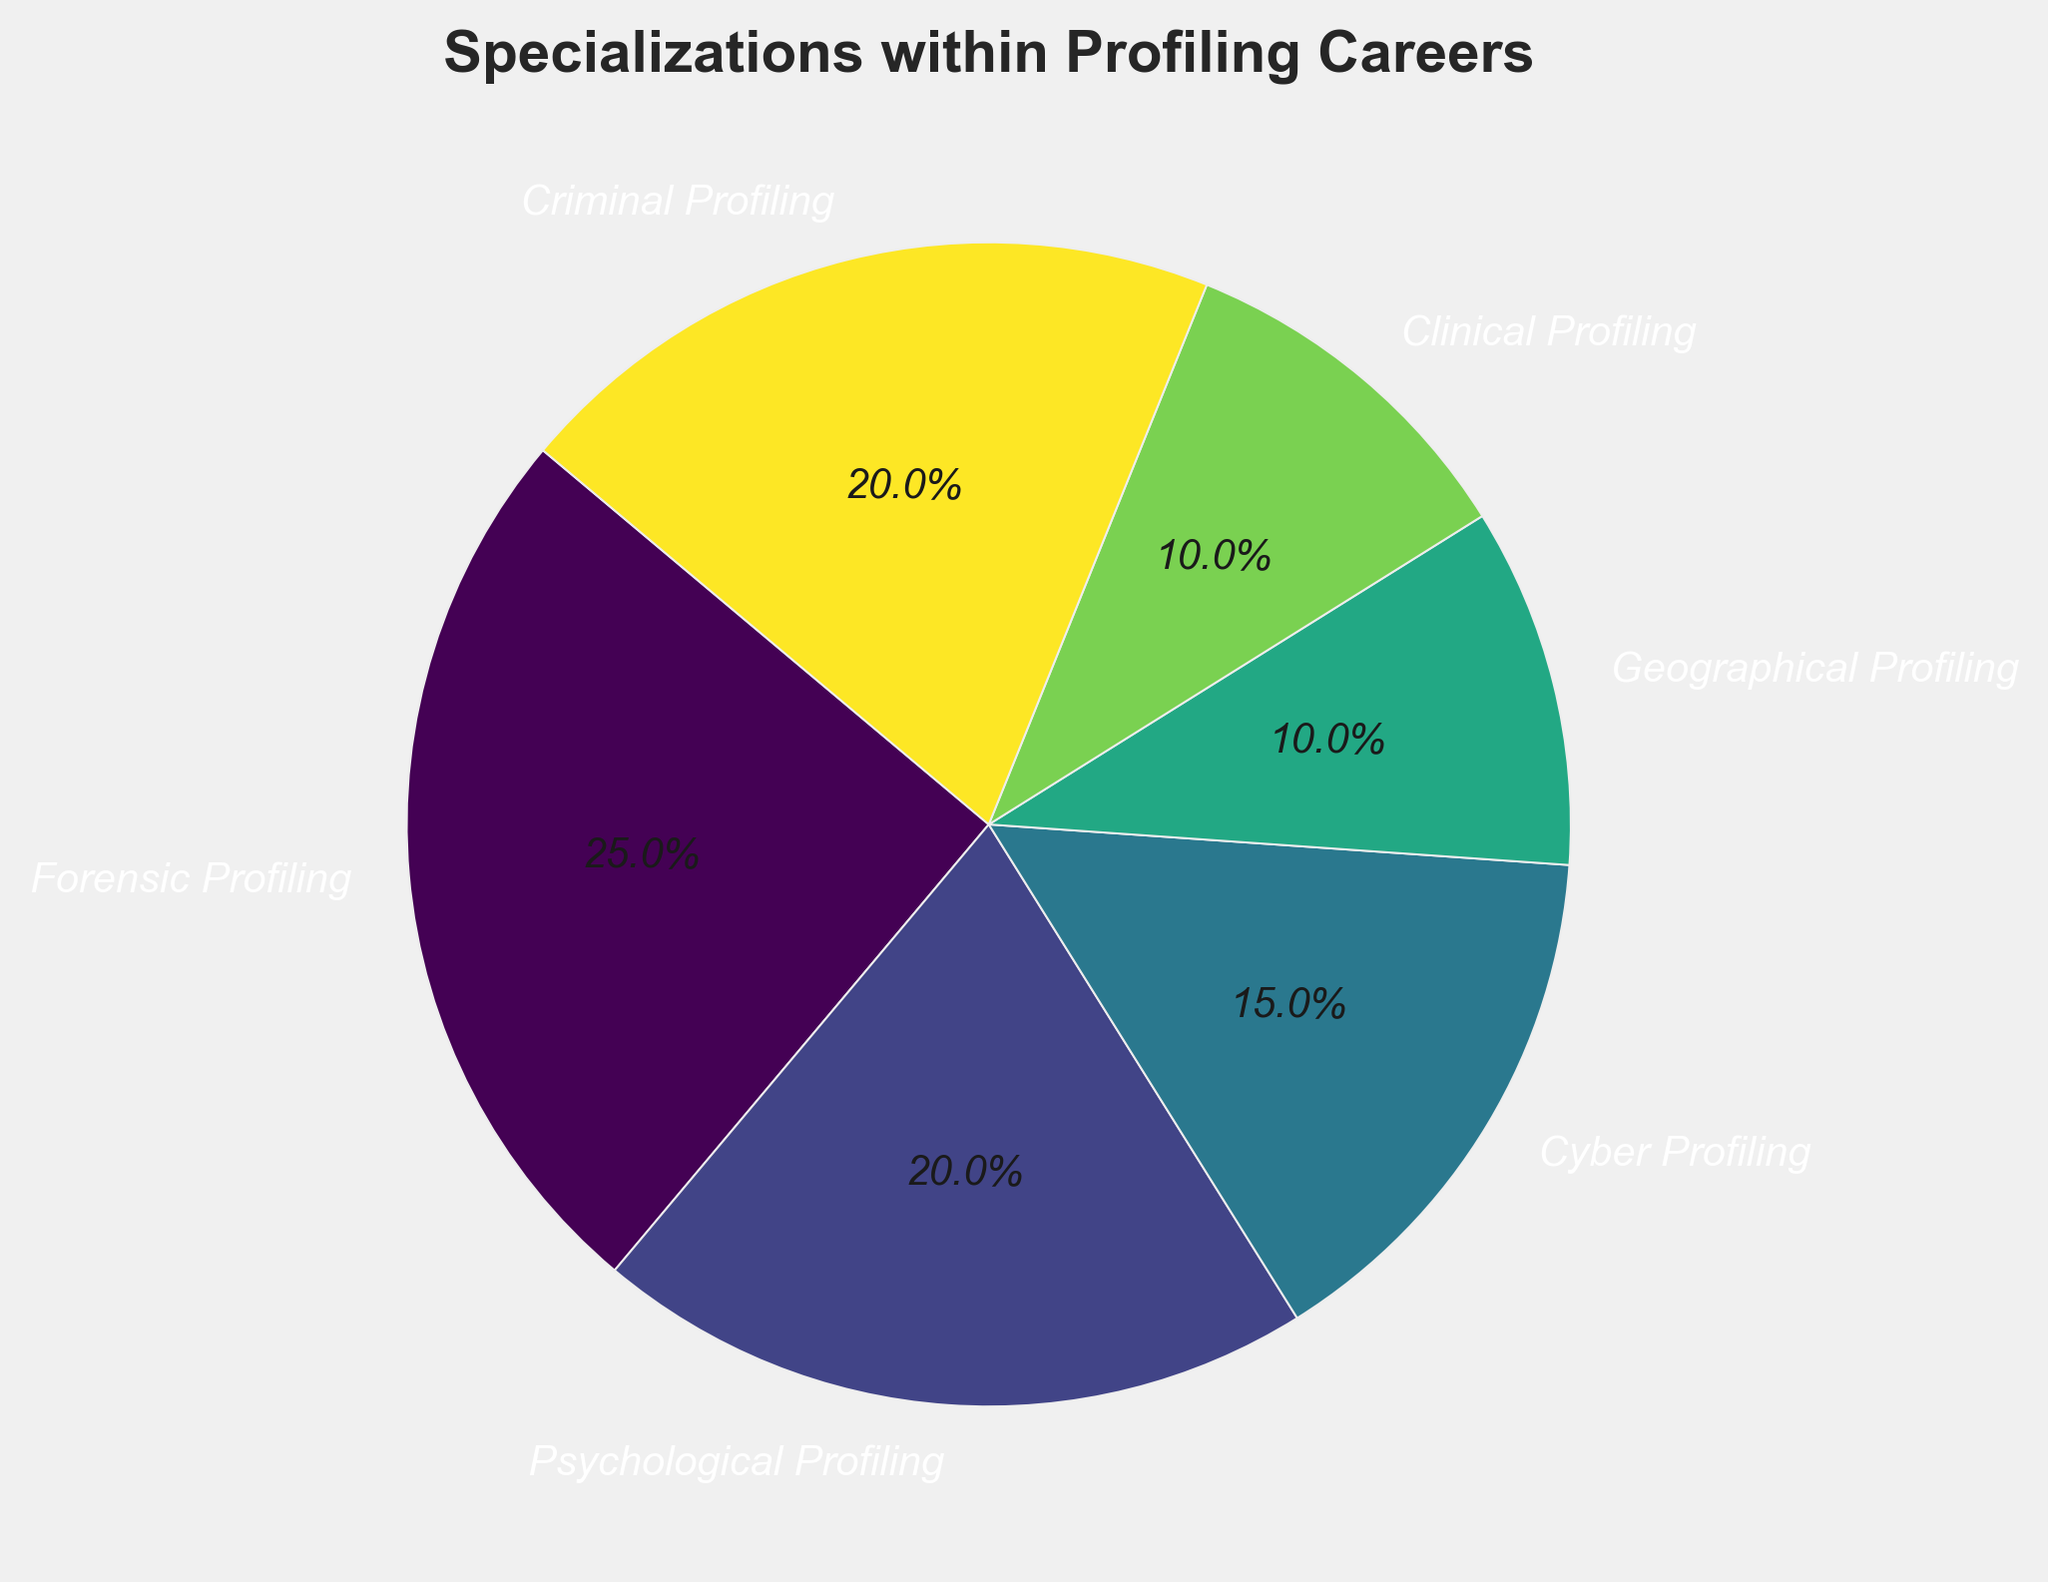What percentage of profiling careers does Clinical Profiling make up? To find this, locate the section labeled "Clinical Profiling" in the pie chart and read the percentage value directly.
Answer: 10% Which specialization has the lowest representation in the pie chart? Identify the section of the pie chart with the smallest slice. In this case, it is the one with the label "Geographical Profiling."
Answer: Geographical Profiling Compare the combined percentage of Forensic Profiling and Criminal Profiling to the combined percentage of Psychological Profiling and Cyber Profiling. Which is larger? Sum the percentages of Forensic Profiling (25) and Criminal Profiling (20) to get 45%. Then, sum the percentages of Psychological Profiling (20) and Cyber Profiling (15) to get 35%. Compare the two sums, and 45% is larger than 35%.
Answer: Forensic and Criminal Profiling What is the ratio of Forensic Profiling to Cyber Profiling? To find the ratio, divide the percentage of Forensic Profiling by the percentage of Cyber Profiling: 25 / 15 = 5/3. Hence, the ratio is 5:3.
Answer: 5:3 If the total number of profiling professionals is 500, how many work in Psychological Profiling? Calculate the number by taking 20% of the total: 500 * 0.20 = 100. So, 100 professionals work in Psychological Profiling.
Answer: 100 Among all the specializations, which two have equal representation? Check the pie chart to see which sections have the same percentage values. Psychological Profiling and Criminal Profiling both have 20%.
Answer: Psychological Profiling and Criminal Profiling How much larger is the percentage of Forensic Profiling compared to Geographical Profiling? Subtract the percentage of Geographical Profiling (10) from the percentage of Forensic Profiling (25): 25 - 10 = 15. Therefore, Forensic Profiling is 15% larger.
Answer: 15% What is the average percentage representation of Clinical Profiling, Criminal Profiling, and Cyber Profiling? Add the percentages: Clinical Profiling (10), Criminal Profiling (20), and Cyber Profiling (15). Then divide by the number of specializations: (10 + 20 + 15) / 3 = 45 / 3 = 15.
Answer: 15% Which specialization uses the lightest color in the pie chart? Identify the color mapping in the pie chart. Typically, lighter colors represent lower values in a gradient. From the data, Geographical Profiling (10%) is likely the lightest.
Answer: Geographical Profiling If a new specialization with 10% were added to the chart, what new percentage would each original specialization represent? Given total expansions to include 110%, Forensic Profiling: (25/110)*100 = 22.73%, Psychological Profiling: 18.18%, Cyber Profiling: 13.64%, Geographical Profiling: 9.09%, Clinical Profiling: 9.09%, Criminal Profiling: 18.18%. (Each old percentage divided by 110 and multiplied by 100 to convert back to percentage)
Answer: Various new percentages detailed above 